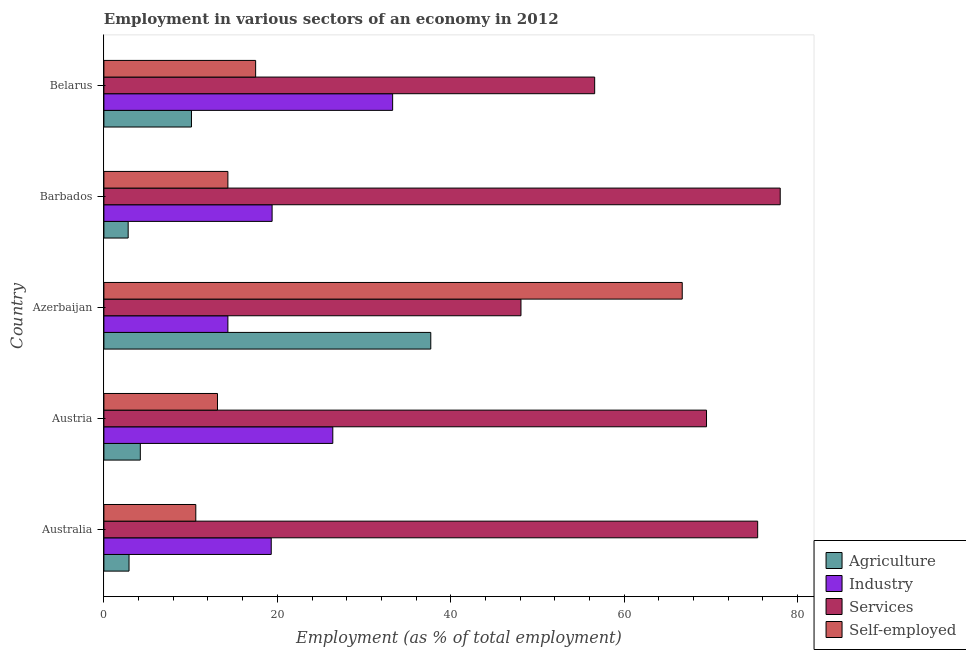How many different coloured bars are there?
Offer a very short reply. 4. Are the number of bars per tick equal to the number of legend labels?
Offer a very short reply. Yes. How many bars are there on the 1st tick from the top?
Provide a short and direct response. 4. How many bars are there on the 1st tick from the bottom?
Your answer should be compact. 4. What is the label of the 1st group of bars from the top?
Offer a very short reply. Belarus. In how many cases, is the number of bars for a given country not equal to the number of legend labels?
Your answer should be compact. 0. What is the percentage of self employed workers in Austria?
Provide a succinct answer. 13.1. Across all countries, what is the maximum percentage of workers in agriculture?
Give a very brief answer. 37.7. Across all countries, what is the minimum percentage of workers in agriculture?
Make the answer very short. 2.8. In which country was the percentage of self employed workers maximum?
Offer a very short reply. Azerbaijan. In which country was the percentage of workers in agriculture minimum?
Your answer should be compact. Barbados. What is the total percentage of workers in agriculture in the graph?
Offer a terse response. 57.7. What is the difference between the percentage of workers in services in Austria and the percentage of workers in agriculture in Azerbaijan?
Provide a short and direct response. 31.8. What is the average percentage of workers in services per country?
Keep it short and to the point. 65.52. What is the difference between the percentage of workers in agriculture and percentage of self employed workers in Austria?
Offer a terse response. -8.9. In how many countries, is the percentage of workers in services greater than 24 %?
Keep it short and to the point. 5. What is the ratio of the percentage of self employed workers in Azerbaijan to that in Barbados?
Keep it short and to the point. 4.66. Is the percentage of self employed workers in Australia less than that in Azerbaijan?
Offer a terse response. Yes. What is the difference between the highest and the second highest percentage of workers in services?
Provide a succinct answer. 2.6. What is the difference between the highest and the lowest percentage of self employed workers?
Your response must be concise. 56.1. What does the 1st bar from the top in Azerbaijan represents?
Offer a very short reply. Self-employed. What does the 2nd bar from the bottom in Barbados represents?
Ensure brevity in your answer.  Industry. Is it the case that in every country, the sum of the percentage of workers in agriculture and percentage of workers in industry is greater than the percentage of workers in services?
Make the answer very short. No. Are all the bars in the graph horizontal?
Keep it short and to the point. Yes. How many countries are there in the graph?
Provide a succinct answer. 5. Are the values on the major ticks of X-axis written in scientific E-notation?
Provide a short and direct response. No. Does the graph contain grids?
Your answer should be very brief. No. How are the legend labels stacked?
Your answer should be very brief. Vertical. What is the title of the graph?
Provide a short and direct response. Employment in various sectors of an economy in 2012. Does "Belgium" appear as one of the legend labels in the graph?
Provide a short and direct response. No. What is the label or title of the X-axis?
Keep it short and to the point. Employment (as % of total employment). What is the Employment (as % of total employment) of Agriculture in Australia?
Make the answer very short. 2.9. What is the Employment (as % of total employment) in Industry in Australia?
Give a very brief answer. 19.3. What is the Employment (as % of total employment) in Services in Australia?
Your response must be concise. 75.4. What is the Employment (as % of total employment) in Self-employed in Australia?
Offer a very short reply. 10.6. What is the Employment (as % of total employment) of Agriculture in Austria?
Give a very brief answer. 4.2. What is the Employment (as % of total employment) in Industry in Austria?
Your response must be concise. 26.4. What is the Employment (as % of total employment) of Services in Austria?
Ensure brevity in your answer.  69.5. What is the Employment (as % of total employment) of Self-employed in Austria?
Offer a very short reply. 13.1. What is the Employment (as % of total employment) of Agriculture in Azerbaijan?
Give a very brief answer. 37.7. What is the Employment (as % of total employment) in Industry in Azerbaijan?
Your response must be concise. 14.3. What is the Employment (as % of total employment) of Services in Azerbaijan?
Offer a terse response. 48.1. What is the Employment (as % of total employment) of Self-employed in Azerbaijan?
Keep it short and to the point. 66.7. What is the Employment (as % of total employment) of Agriculture in Barbados?
Your answer should be compact. 2.8. What is the Employment (as % of total employment) of Industry in Barbados?
Your answer should be compact. 19.4. What is the Employment (as % of total employment) of Services in Barbados?
Offer a very short reply. 78. What is the Employment (as % of total employment) of Self-employed in Barbados?
Make the answer very short. 14.3. What is the Employment (as % of total employment) in Agriculture in Belarus?
Ensure brevity in your answer.  10.1. What is the Employment (as % of total employment) in Industry in Belarus?
Offer a very short reply. 33.3. What is the Employment (as % of total employment) in Services in Belarus?
Provide a short and direct response. 56.6. Across all countries, what is the maximum Employment (as % of total employment) of Agriculture?
Your answer should be compact. 37.7. Across all countries, what is the maximum Employment (as % of total employment) in Industry?
Ensure brevity in your answer.  33.3. Across all countries, what is the maximum Employment (as % of total employment) of Services?
Provide a short and direct response. 78. Across all countries, what is the maximum Employment (as % of total employment) in Self-employed?
Offer a terse response. 66.7. Across all countries, what is the minimum Employment (as % of total employment) in Agriculture?
Your answer should be compact. 2.8. Across all countries, what is the minimum Employment (as % of total employment) in Industry?
Provide a succinct answer. 14.3. Across all countries, what is the minimum Employment (as % of total employment) in Services?
Ensure brevity in your answer.  48.1. Across all countries, what is the minimum Employment (as % of total employment) of Self-employed?
Keep it short and to the point. 10.6. What is the total Employment (as % of total employment) in Agriculture in the graph?
Make the answer very short. 57.7. What is the total Employment (as % of total employment) in Industry in the graph?
Provide a succinct answer. 112.7. What is the total Employment (as % of total employment) in Services in the graph?
Provide a succinct answer. 327.6. What is the total Employment (as % of total employment) in Self-employed in the graph?
Make the answer very short. 122.2. What is the difference between the Employment (as % of total employment) of Agriculture in Australia and that in Austria?
Your response must be concise. -1.3. What is the difference between the Employment (as % of total employment) of Self-employed in Australia and that in Austria?
Keep it short and to the point. -2.5. What is the difference between the Employment (as % of total employment) of Agriculture in Australia and that in Azerbaijan?
Provide a short and direct response. -34.8. What is the difference between the Employment (as % of total employment) in Services in Australia and that in Azerbaijan?
Offer a very short reply. 27.3. What is the difference between the Employment (as % of total employment) in Self-employed in Australia and that in Azerbaijan?
Provide a succinct answer. -56.1. What is the difference between the Employment (as % of total employment) in Industry in Australia and that in Barbados?
Your answer should be very brief. -0.1. What is the difference between the Employment (as % of total employment) of Services in Australia and that in Barbados?
Keep it short and to the point. -2.6. What is the difference between the Employment (as % of total employment) of Self-employed in Australia and that in Barbados?
Provide a succinct answer. -3.7. What is the difference between the Employment (as % of total employment) in Industry in Australia and that in Belarus?
Make the answer very short. -14. What is the difference between the Employment (as % of total employment) of Services in Australia and that in Belarus?
Your answer should be very brief. 18.8. What is the difference between the Employment (as % of total employment) of Self-employed in Australia and that in Belarus?
Keep it short and to the point. -6.9. What is the difference between the Employment (as % of total employment) in Agriculture in Austria and that in Azerbaijan?
Offer a very short reply. -33.5. What is the difference between the Employment (as % of total employment) in Industry in Austria and that in Azerbaijan?
Offer a terse response. 12.1. What is the difference between the Employment (as % of total employment) of Services in Austria and that in Azerbaijan?
Your answer should be very brief. 21.4. What is the difference between the Employment (as % of total employment) of Self-employed in Austria and that in Azerbaijan?
Provide a short and direct response. -53.6. What is the difference between the Employment (as % of total employment) in Agriculture in Austria and that in Barbados?
Your answer should be very brief. 1.4. What is the difference between the Employment (as % of total employment) of Self-employed in Austria and that in Barbados?
Offer a very short reply. -1.2. What is the difference between the Employment (as % of total employment) in Agriculture in Azerbaijan and that in Barbados?
Provide a short and direct response. 34.9. What is the difference between the Employment (as % of total employment) of Services in Azerbaijan and that in Barbados?
Offer a terse response. -29.9. What is the difference between the Employment (as % of total employment) in Self-employed in Azerbaijan and that in Barbados?
Your response must be concise. 52.4. What is the difference between the Employment (as % of total employment) in Agriculture in Azerbaijan and that in Belarus?
Keep it short and to the point. 27.6. What is the difference between the Employment (as % of total employment) in Industry in Azerbaijan and that in Belarus?
Your response must be concise. -19. What is the difference between the Employment (as % of total employment) in Services in Azerbaijan and that in Belarus?
Your answer should be very brief. -8.5. What is the difference between the Employment (as % of total employment) in Self-employed in Azerbaijan and that in Belarus?
Make the answer very short. 49.2. What is the difference between the Employment (as % of total employment) in Agriculture in Barbados and that in Belarus?
Give a very brief answer. -7.3. What is the difference between the Employment (as % of total employment) in Services in Barbados and that in Belarus?
Keep it short and to the point. 21.4. What is the difference between the Employment (as % of total employment) of Agriculture in Australia and the Employment (as % of total employment) of Industry in Austria?
Ensure brevity in your answer.  -23.5. What is the difference between the Employment (as % of total employment) of Agriculture in Australia and the Employment (as % of total employment) of Services in Austria?
Ensure brevity in your answer.  -66.6. What is the difference between the Employment (as % of total employment) in Industry in Australia and the Employment (as % of total employment) in Services in Austria?
Keep it short and to the point. -50.2. What is the difference between the Employment (as % of total employment) in Services in Australia and the Employment (as % of total employment) in Self-employed in Austria?
Provide a short and direct response. 62.3. What is the difference between the Employment (as % of total employment) in Agriculture in Australia and the Employment (as % of total employment) in Industry in Azerbaijan?
Give a very brief answer. -11.4. What is the difference between the Employment (as % of total employment) of Agriculture in Australia and the Employment (as % of total employment) of Services in Azerbaijan?
Provide a short and direct response. -45.2. What is the difference between the Employment (as % of total employment) of Agriculture in Australia and the Employment (as % of total employment) of Self-employed in Azerbaijan?
Your answer should be compact. -63.8. What is the difference between the Employment (as % of total employment) of Industry in Australia and the Employment (as % of total employment) of Services in Azerbaijan?
Make the answer very short. -28.8. What is the difference between the Employment (as % of total employment) of Industry in Australia and the Employment (as % of total employment) of Self-employed in Azerbaijan?
Offer a terse response. -47.4. What is the difference between the Employment (as % of total employment) in Agriculture in Australia and the Employment (as % of total employment) in Industry in Barbados?
Offer a very short reply. -16.5. What is the difference between the Employment (as % of total employment) of Agriculture in Australia and the Employment (as % of total employment) of Services in Barbados?
Ensure brevity in your answer.  -75.1. What is the difference between the Employment (as % of total employment) in Agriculture in Australia and the Employment (as % of total employment) in Self-employed in Barbados?
Provide a short and direct response. -11.4. What is the difference between the Employment (as % of total employment) of Industry in Australia and the Employment (as % of total employment) of Services in Barbados?
Offer a terse response. -58.7. What is the difference between the Employment (as % of total employment) of Services in Australia and the Employment (as % of total employment) of Self-employed in Barbados?
Provide a succinct answer. 61.1. What is the difference between the Employment (as % of total employment) of Agriculture in Australia and the Employment (as % of total employment) of Industry in Belarus?
Keep it short and to the point. -30.4. What is the difference between the Employment (as % of total employment) in Agriculture in Australia and the Employment (as % of total employment) in Services in Belarus?
Keep it short and to the point. -53.7. What is the difference between the Employment (as % of total employment) of Agriculture in Australia and the Employment (as % of total employment) of Self-employed in Belarus?
Your answer should be very brief. -14.6. What is the difference between the Employment (as % of total employment) in Industry in Australia and the Employment (as % of total employment) in Services in Belarus?
Your response must be concise. -37.3. What is the difference between the Employment (as % of total employment) of Industry in Australia and the Employment (as % of total employment) of Self-employed in Belarus?
Ensure brevity in your answer.  1.8. What is the difference between the Employment (as % of total employment) of Services in Australia and the Employment (as % of total employment) of Self-employed in Belarus?
Keep it short and to the point. 57.9. What is the difference between the Employment (as % of total employment) of Agriculture in Austria and the Employment (as % of total employment) of Industry in Azerbaijan?
Offer a very short reply. -10.1. What is the difference between the Employment (as % of total employment) of Agriculture in Austria and the Employment (as % of total employment) of Services in Azerbaijan?
Your answer should be very brief. -43.9. What is the difference between the Employment (as % of total employment) in Agriculture in Austria and the Employment (as % of total employment) in Self-employed in Azerbaijan?
Provide a short and direct response. -62.5. What is the difference between the Employment (as % of total employment) of Industry in Austria and the Employment (as % of total employment) of Services in Azerbaijan?
Provide a succinct answer. -21.7. What is the difference between the Employment (as % of total employment) in Industry in Austria and the Employment (as % of total employment) in Self-employed in Azerbaijan?
Offer a terse response. -40.3. What is the difference between the Employment (as % of total employment) in Agriculture in Austria and the Employment (as % of total employment) in Industry in Barbados?
Provide a short and direct response. -15.2. What is the difference between the Employment (as % of total employment) of Agriculture in Austria and the Employment (as % of total employment) of Services in Barbados?
Offer a very short reply. -73.8. What is the difference between the Employment (as % of total employment) in Agriculture in Austria and the Employment (as % of total employment) in Self-employed in Barbados?
Provide a succinct answer. -10.1. What is the difference between the Employment (as % of total employment) of Industry in Austria and the Employment (as % of total employment) of Services in Barbados?
Provide a succinct answer. -51.6. What is the difference between the Employment (as % of total employment) in Industry in Austria and the Employment (as % of total employment) in Self-employed in Barbados?
Offer a terse response. 12.1. What is the difference between the Employment (as % of total employment) of Services in Austria and the Employment (as % of total employment) of Self-employed in Barbados?
Keep it short and to the point. 55.2. What is the difference between the Employment (as % of total employment) in Agriculture in Austria and the Employment (as % of total employment) in Industry in Belarus?
Your response must be concise. -29.1. What is the difference between the Employment (as % of total employment) in Agriculture in Austria and the Employment (as % of total employment) in Services in Belarus?
Your response must be concise. -52.4. What is the difference between the Employment (as % of total employment) of Industry in Austria and the Employment (as % of total employment) of Services in Belarus?
Your answer should be compact. -30.2. What is the difference between the Employment (as % of total employment) of Services in Austria and the Employment (as % of total employment) of Self-employed in Belarus?
Provide a short and direct response. 52. What is the difference between the Employment (as % of total employment) in Agriculture in Azerbaijan and the Employment (as % of total employment) in Services in Barbados?
Make the answer very short. -40.3. What is the difference between the Employment (as % of total employment) in Agriculture in Azerbaijan and the Employment (as % of total employment) in Self-employed in Barbados?
Your answer should be compact. 23.4. What is the difference between the Employment (as % of total employment) in Industry in Azerbaijan and the Employment (as % of total employment) in Services in Barbados?
Provide a succinct answer. -63.7. What is the difference between the Employment (as % of total employment) of Industry in Azerbaijan and the Employment (as % of total employment) of Self-employed in Barbados?
Make the answer very short. 0. What is the difference between the Employment (as % of total employment) in Services in Azerbaijan and the Employment (as % of total employment) in Self-employed in Barbados?
Offer a very short reply. 33.8. What is the difference between the Employment (as % of total employment) in Agriculture in Azerbaijan and the Employment (as % of total employment) in Services in Belarus?
Provide a succinct answer. -18.9. What is the difference between the Employment (as % of total employment) of Agriculture in Azerbaijan and the Employment (as % of total employment) of Self-employed in Belarus?
Provide a short and direct response. 20.2. What is the difference between the Employment (as % of total employment) of Industry in Azerbaijan and the Employment (as % of total employment) of Services in Belarus?
Ensure brevity in your answer.  -42.3. What is the difference between the Employment (as % of total employment) of Services in Azerbaijan and the Employment (as % of total employment) of Self-employed in Belarus?
Your answer should be compact. 30.6. What is the difference between the Employment (as % of total employment) in Agriculture in Barbados and the Employment (as % of total employment) in Industry in Belarus?
Offer a terse response. -30.5. What is the difference between the Employment (as % of total employment) of Agriculture in Barbados and the Employment (as % of total employment) of Services in Belarus?
Your answer should be very brief. -53.8. What is the difference between the Employment (as % of total employment) in Agriculture in Barbados and the Employment (as % of total employment) in Self-employed in Belarus?
Offer a terse response. -14.7. What is the difference between the Employment (as % of total employment) of Industry in Barbados and the Employment (as % of total employment) of Services in Belarus?
Offer a terse response. -37.2. What is the difference between the Employment (as % of total employment) in Services in Barbados and the Employment (as % of total employment) in Self-employed in Belarus?
Offer a very short reply. 60.5. What is the average Employment (as % of total employment) of Agriculture per country?
Your answer should be very brief. 11.54. What is the average Employment (as % of total employment) of Industry per country?
Your answer should be compact. 22.54. What is the average Employment (as % of total employment) of Services per country?
Offer a very short reply. 65.52. What is the average Employment (as % of total employment) in Self-employed per country?
Your answer should be very brief. 24.44. What is the difference between the Employment (as % of total employment) of Agriculture and Employment (as % of total employment) of Industry in Australia?
Keep it short and to the point. -16.4. What is the difference between the Employment (as % of total employment) in Agriculture and Employment (as % of total employment) in Services in Australia?
Make the answer very short. -72.5. What is the difference between the Employment (as % of total employment) of Agriculture and Employment (as % of total employment) of Self-employed in Australia?
Keep it short and to the point. -7.7. What is the difference between the Employment (as % of total employment) of Industry and Employment (as % of total employment) of Services in Australia?
Your response must be concise. -56.1. What is the difference between the Employment (as % of total employment) of Services and Employment (as % of total employment) of Self-employed in Australia?
Your answer should be compact. 64.8. What is the difference between the Employment (as % of total employment) in Agriculture and Employment (as % of total employment) in Industry in Austria?
Ensure brevity in your answer.  -22.2. What is the difference between the Employment (as % of total employment) of Agriculture and Employment (as % of total employment) of Services in Austria?
Provide a short and direct response. -65.3. What is the difference between the Employment (as % of total employment) in Agriculture and Employment (as % of total employment) in Self-employed in Austria?
Keep it short and to the point. -8.9. What is the difference between the Employment (as % of total employment) of Industry and Employment (as % of total employment) of Services in Austria?
Make the answer very short. -43.1. What is the difference between the Employment (as % of total employment) of Industry and Employment (as % of total employment) of Self-employed in Austria?
Offer a terse response. 13.3. What is the difference between the Employment (as % of total employment) in Services and Employment (as % of total employment) in Self-employed in Austria?
Give a very brief answer. 56.4. What is the difference between the Employment (as % of total employment) in Agriculture and Employment (as % of total employment) in Industry in Azerbaijan?
Offer a very short reply. 23.4. What is the difference between the Employment (as % of total employment) in Industry and Employment (as % of total employment) in Services in Azerbaijan?
Keep it short and to the point. -33.8. What is the difference between the Employment (as % of total employment) of Industry and Employment (as % of total employment) of Self-employed in Azerbaijan?
Offer a very short reply. -52.4. What is the difference between the Employment (as % of total employment) of Services and Employment (as % of total employment) of Self-employed in Azerbaijan?
Provide a succinct answer. -18.6. What is the difference between the Employment (as % of total employment) of Agriculture and Employment (as % of total employment) of Industry in Barbados?
Provide a succinct answer. -16.6. What is the difference between the Employment (as % of total employment) in Agriculture and Employment (as % of total employment) in Services in Barbados?
Provide a succinct answer. -75.2. What is the difference between the Employment (as % of total employment) in Industry and Employment (as % of total employment) in Services in Barbados?
Provide a succinct answer. -58.6. What is the difference between the Employment (as % of total employment) in Services and Employment (as % of total employment) in Self-employed in Barbados?
Provide a succinct answer. 63.7. What is the difference between the Employment (as % of total employment) of Agriculture and Employment (as % of total employment) of Industry in Belarus?
Provide a short and direct response. -23.2. What is the difference between the Employment (as % of total employment) in Agriculture and Employment (as % of total employment) in Services in Belarus?
Give a very brief answer. -46.5. What is the difference between the Employment (as % of total employment) in Industry and Employment (as % of total employment) in Services in Belarus?
Your answer should be very brief. -23.3. What is the difference between the Employment (as % of total employment) of Industry and Employment (as % of total employment) of Self-employed in Belarus?
Your answer should be compact. 15.8. What is the difference between the Employment (as % of total employment) of Services and Employment (as % of total employment) of Self-employed in Belarus?
Your answer should be very brief. 39.1. What is the ratio of the Employment (as % of total employment) of Agriculture in Australia to that in Austria?
Your answer should be very brief. 0.69. What is the ratio of the Employment (as % of total employment) in Industry in Australia to that in Austria?
Provide a short and direct response. 0.73. What is the ratio of the Employment (as % of total employment) of Services in Australia to that in Austria?
Your response must be concise. 1.08. What is the ratio of the Employment (as % of total employment) in Self-employed in Australia to that in Austria?
Provide a succinct answer. 0.81. What is the ratio of the Employment (as % of total employment) of Agriculture in Australia to that in Azerbaijan?
Your answer should be very brief. 0.08. What is the ratio of the Employment (as % of total employment) of Industry in Australia to that in Azerbaijan?
Your answer should be very brief. 1.35. What is the ratio of the Employment (as % of total employment) in Services in Australia to that in Azerbaijan?
Offer a very short reply. 1.57. What is the ratio of the Employment (as % of total employment) of Self-employed in Australia to that in Azerbaijan?
Offer a terse response. 0.16. What is the ratio of the Employment (as % of total employment) in Agriculture in Australia to that in Barbados?
Provide a succinct answer. 1.04. What is the ratio of the Employment (as % of total employment) of Services in Australia to that in Barbados?
Your answer should be very brief. 0.97. What is the ratio of the Employment (as % of total employment) of Self-employed in Australia to that in Barbados?
Give a very brief answer. 0.74. What is the ratio of the Employment (as % of total employment) in Agriculture in Australia to that in Belarus?
Your answer should be very brief. 0.29. What is the ratio of the Employment (as % of total employment) in Industry in Australia to that in Belarus?
Provide a succinct answer. 0.58. What is the ratio of the Employment (as % of total employment) in Services in Australia to that in Belarus?
Ensure brevity in your answer.  1.33. What is the ratio of the Employment (as % of total employment) of Self-employed in Australia to that in Belarus?
Your response must be concise. 0.61. What is the ratio of the Employment (as % of total employment) in Agriculture in Austria to that in Azerbaijan?
Offer a terse response. 0.11. What is the ratio of the Employment (as % of total employment) of Industry in Austria to that in Azerbaijan?
Your answer should be compact. 1.85. What is the ratio of the Employment (as % of total employment) in Services in Austria to that in Azerbaijan?
Make the answer very short. 1.44. What is the ratio of the Employment (as % of total employment) in Self-employed in Austria to that in Azerbaijan?
Offer a very short reply. 0.2. What is the ratio of the Employment (as % of total employment) in Agriculture in Austria to that in Barbados?
Offer a terse response. 1.5. What is the ratio of the Employment (as % of total employment) in Industry in Austria to that in Barbados?
Provide a short and direct response. 1.36. What is the ratio of the Employment (as % of total employment) of Services in Austria to that in Barbados?
Provide a succinct answer. 0.89. What is the ratio of the Employment (as % of total employment) of Self-employed in Austria to that in Barbados?
Ensure brevity in your answer.  0.92. What is the ratio of the Employment (as % of total employment) of Agriculture in Austria to that in Belarus?
Your answer should be very brief. 0.42. What is the ratio of the Employment (as % of total employment) of Industry in Austria to that in Belarus?
Your answer should be very brief. 0.79. What is the ratio of the Employment (as % of total employment) of Services in Austria to that in Belarus?
Your answer should be very brief. 1.23. What is the ratio of the Employment (as % of total employment) in Self-employed in Austria to that in Belarus?
Make the answer very short. 0.75. What is the ratio of the Employment (as % of total employment) of Agriculture in Azerbaijan to that in Barbados?
Offer a terse response. 13.46. What is the ratio of the Employment (as % of total employment) of Industry in Azerbaijan to that in Barbados?
Make the answer very short. 0.74. What is the ratio of the Employment (as % of total employment) in Services in Azerbaijan to that in Barbados?
Your answer should be very brief. 0.62. What is the ratio of the Employment (as % of total employment) in Self-employed in Azerbaijan to that in Barbados?
Make the answer very short. 4.66. What is the ratio of the Employment (as % of total employment) in Agriculture in Azerbaijan to that in Belarus?
Your answer should be compact. 3.73. What is the ratio of the Employment (as % of total employment) in Industry in Azerbaijan to that in Belarus?
Provide a short and direct response. 0.43. What is the ratio of the Employment (as % of total employment) of Services in Azerbaijan to that in Belarus?
Provide a short and direct response. 0.85. What is the ratio of the Employment (as % of total employment) in Self-employed in Azerbaijan to that in Belarus?
Make the answer very short. 3.81. What is the ratio of the Employment (as % of total employment) in Agriculture in Barbados to that in Belarus?
Your response must be concise. 0.28. What is the ratio of the Employment (as % of total employment) of Industry in Barbados to that in Belarus?
Make the answer very short. 0.58. What is the ratio of the Employment (as % of total employment) in Services in Barbados to that in Belarus?
Your answer should be very brief. 1.38. What is the ratio of the Employment (as % of total employment) in Self-employed in Barbados to that in Belarus?
Keep it short and to the point. 0.82. What is the difference between the highest and the second highest Employment (as % of total employment) in Agriculture?
Keep it short and to the point. 27.6. What is the difference between the highest and the second highest Employment (as % of total employment) of Self-employed?
Offer a terse response. 49.2. What is the difference between the highest and the lowest Employment (as % of total employment) in Agriculture?
Provide a succinct answer. 34.9. What is the difference between the highest and the lowest Employment (as % of total employment) in Industry?
Keep it short and to the point. 19. What is the difference between the highest and the lowest Employment (as % of total employment) of Services?
Ensure brevity in your answer.  29.9. What is the difference between the highest and the lowest Employment (as % of total employment) of Self-employed?
Keep it short and to the point. 56.1. 